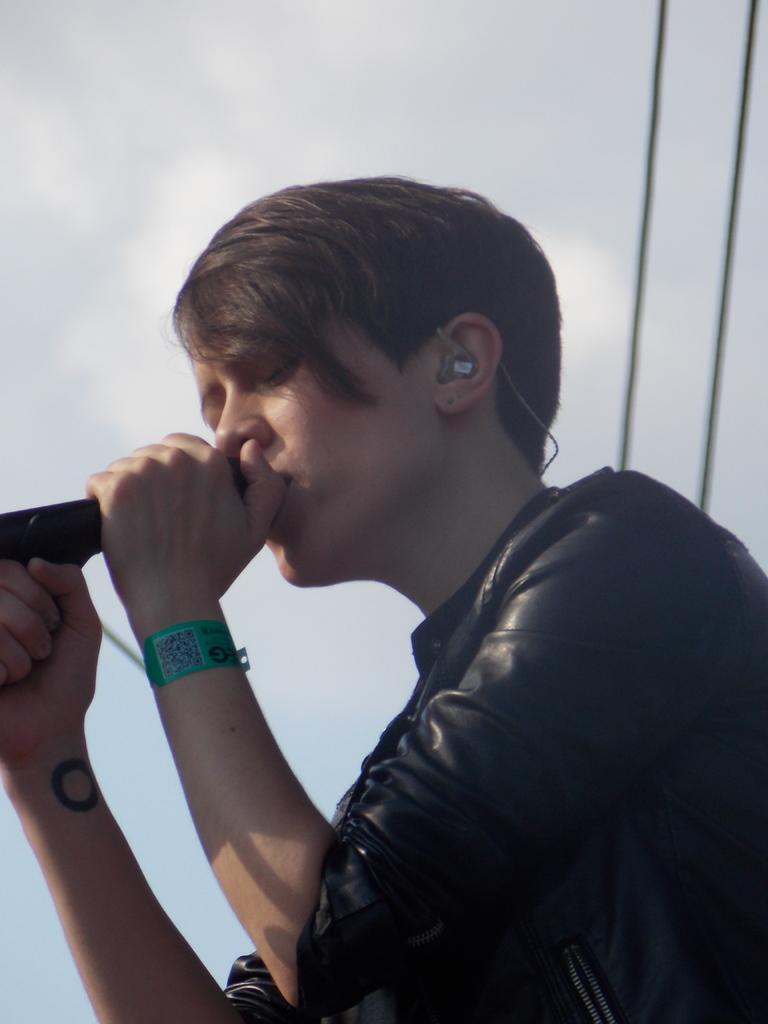Who is the main subject in the image? There is a man in the image. What is the man holding in his hand? The man is holding a microphone in his hand. What can be seen in the background of the image? There is sky visible in the background of the image, and there are also wires present. What type of teeth can be seen in the image? There are no teeth visible in the image. Is the field visible in the image? There is no field present in the image; it features a man holding a microphone with sky and wires in the background. 